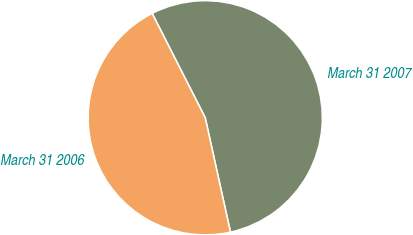<chart> <loc_0><loc_0><loc_500><loc_500><pie_chart><fcel>March 31 2007<fcel>March 31 2006<nl><fcel>54.03%<fcel>45.97%<nl></chart> 